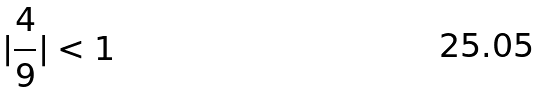<formula> <loc_0><loc_0><loc_500><loc_500>| \frac { 4 } { 9 } | < 1</formula> 